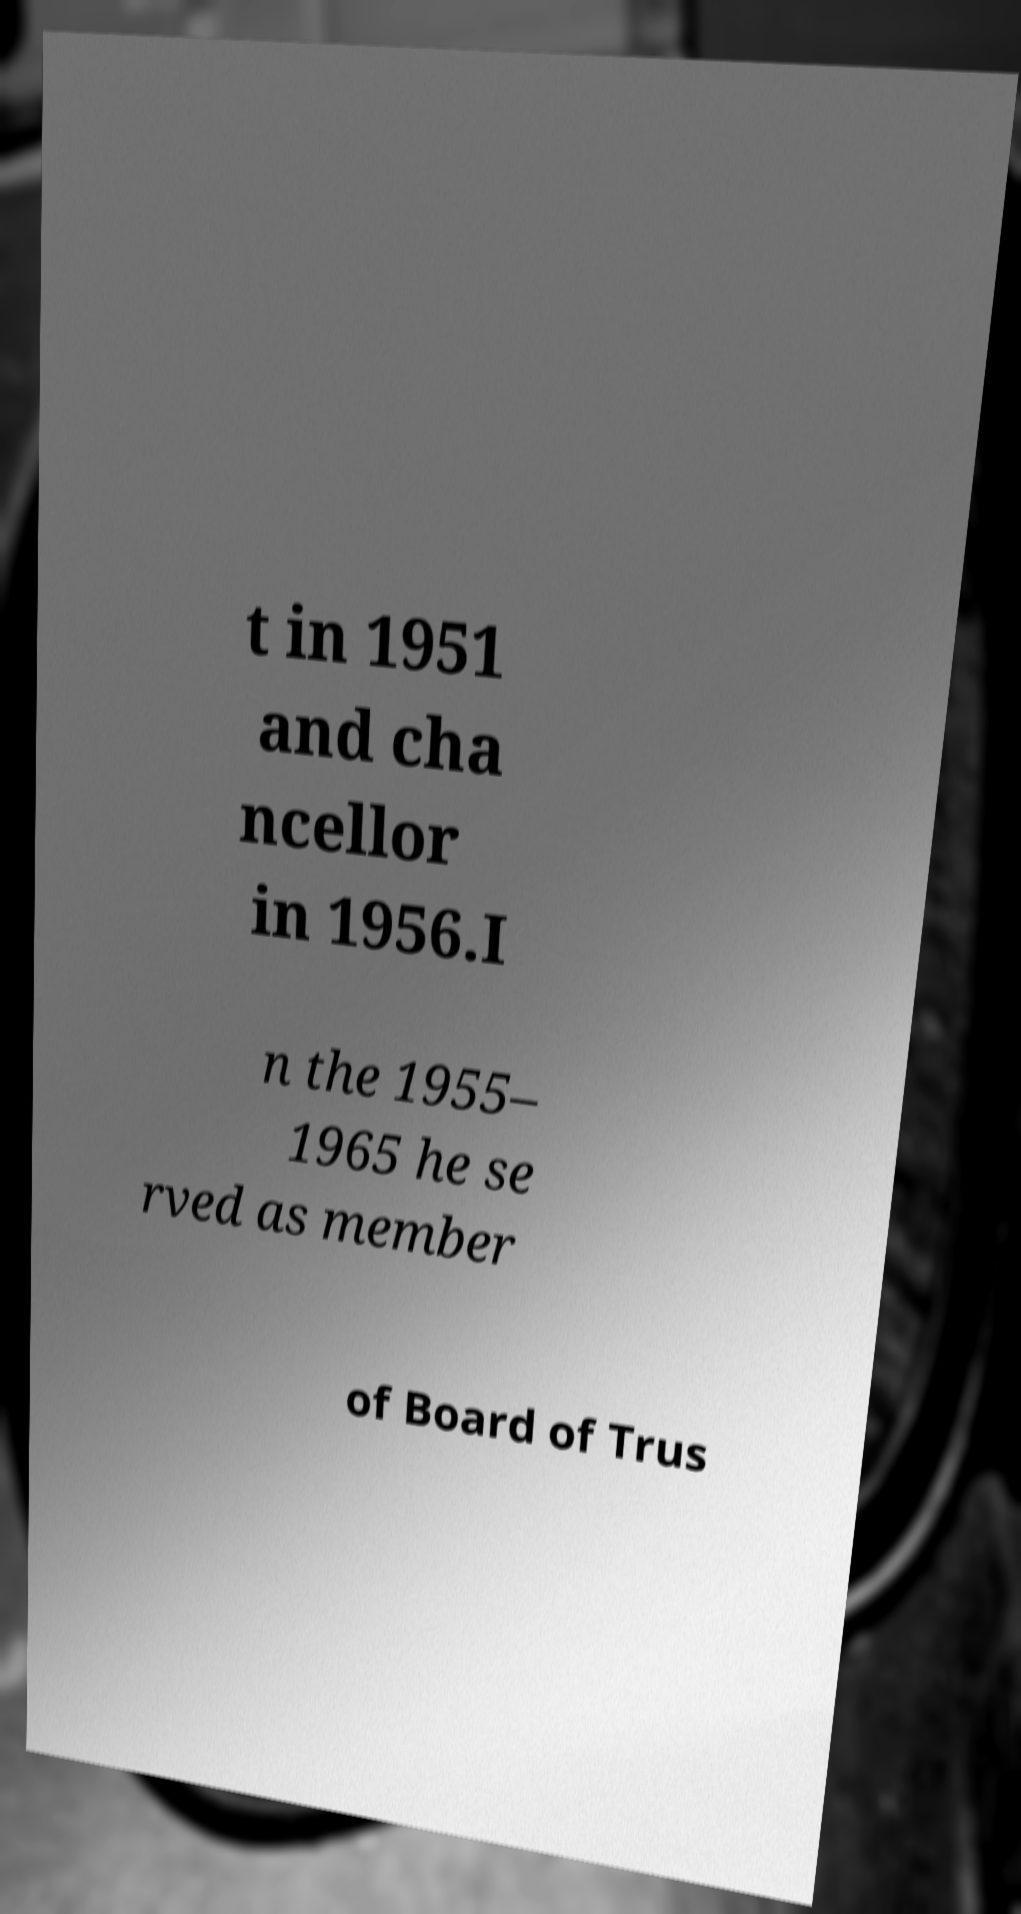I need the written content from this picture converted into text. Can you do that? t in 1951 and cha ncellor in 1956.I n the 1955– 1965 he se rved as member of Board of Trus 